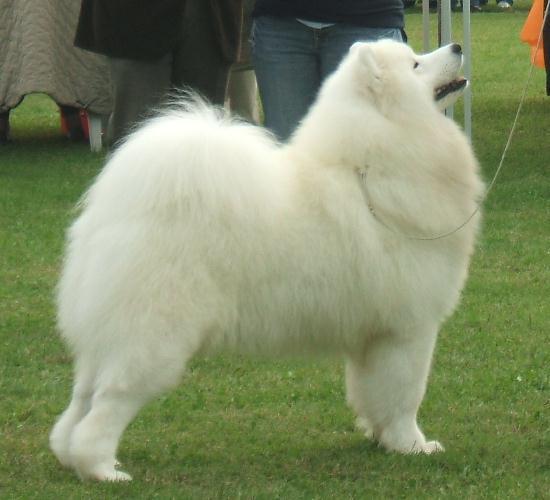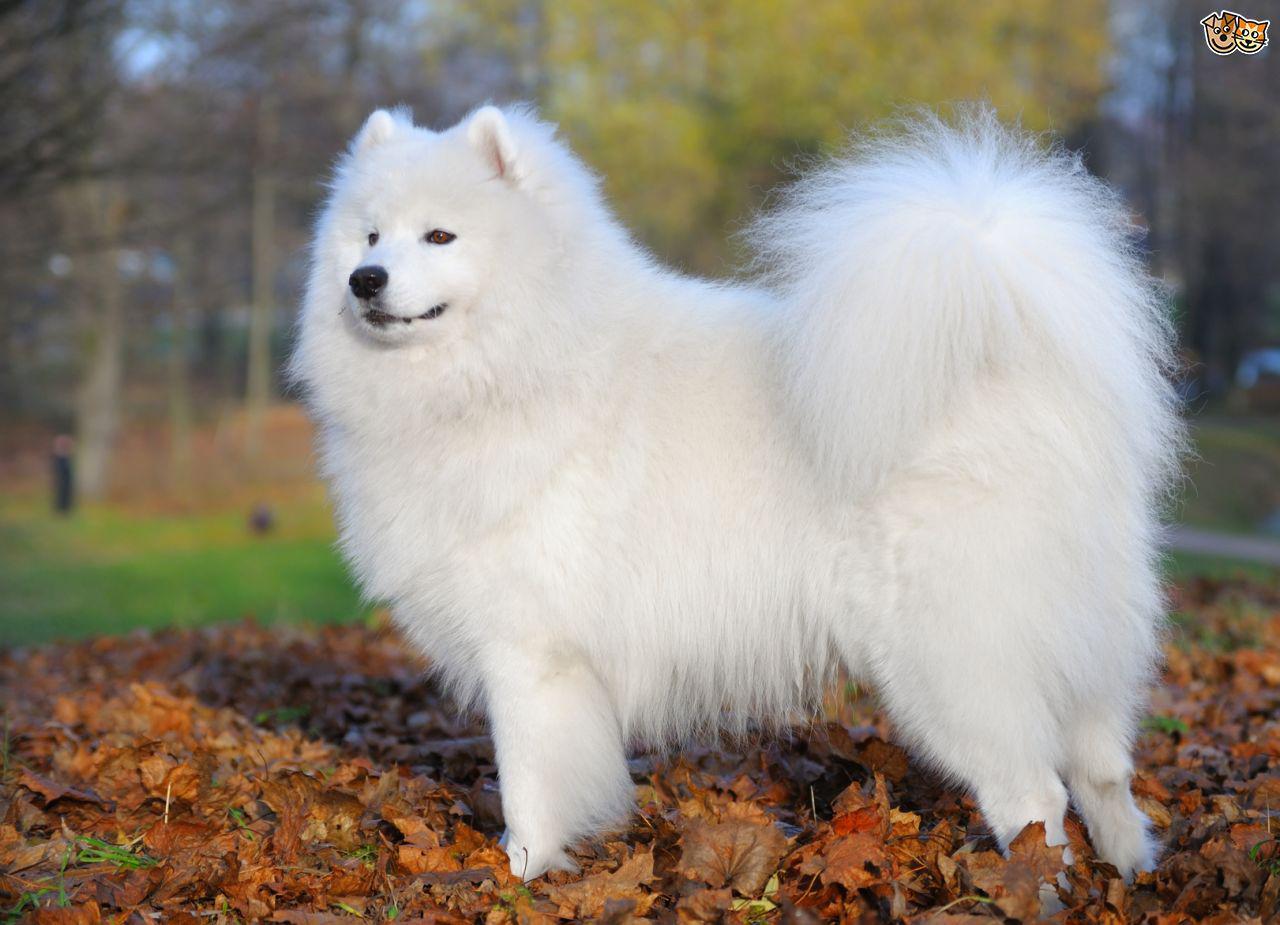The first image is the image on the left, the second image is the image on the right. Given the left and right images, does the statement "One dog is facing the right and one dog is facing the left." hold true? Answer yes or no. Yes. 